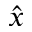Convert formula to latex. <formula><loc_0><loc_0><loc_500><loc_500>\hat { x }</formula> 